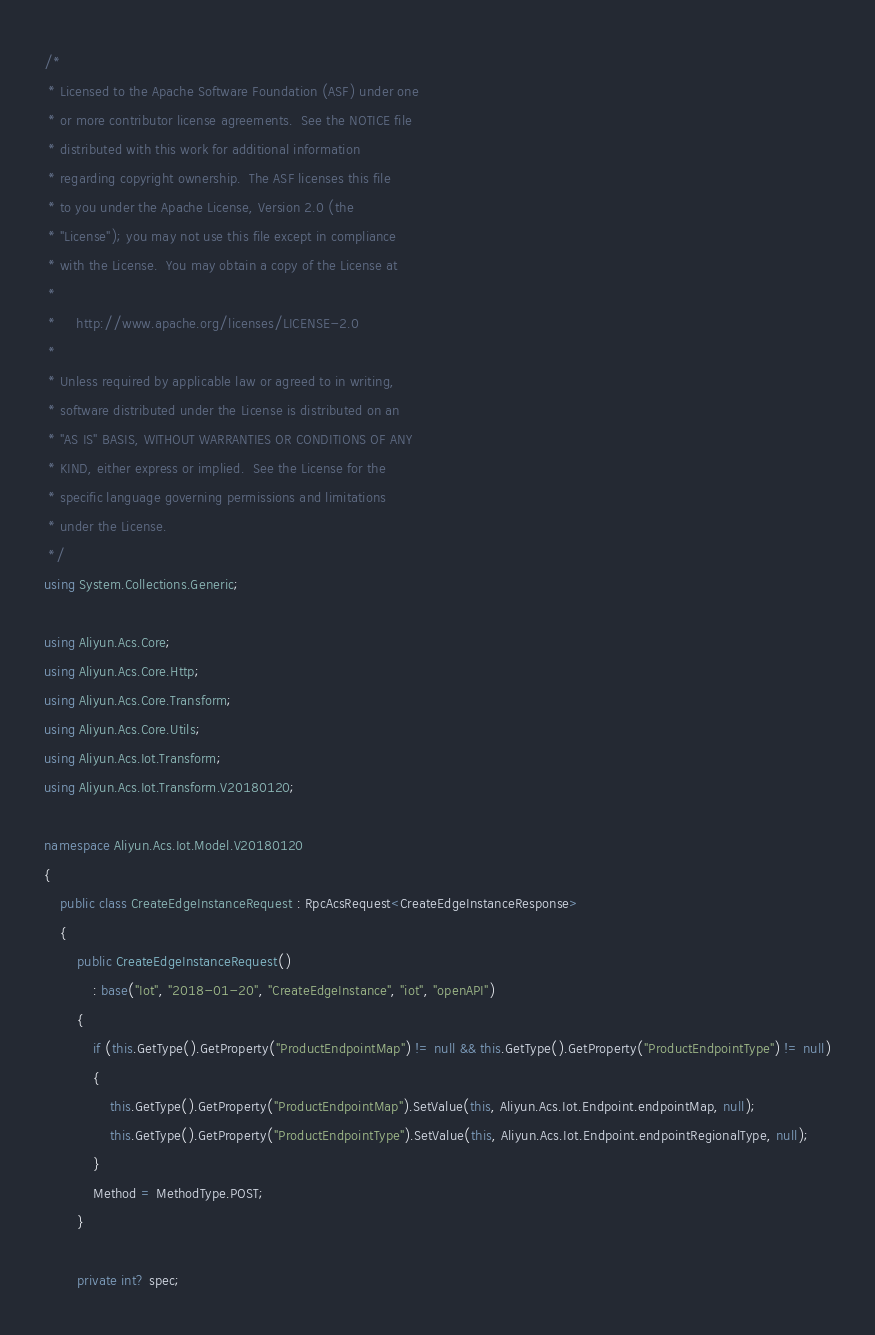Convert code to text. <code><loc_0><loc_0><loc_500><loc_500><_C#_>/*
 * Licensed to the Apache Software Foundation (ASF) under one
 * or more contributor license agreements.  See the NOTICE file
 * distributed with this work for additional information
 * regarding copyright ownership.  The ASF licenses this file
 * to you under the Apache License, Version 2.0 (the
 * "License"); you may not use this file except in compliance
 * with the License.  You may obtain a copy of the License at
 *
 *     http://www.apache.org/licenses/LICENSE-2.0
 *
 * Unless required by applicable law or agreed to in writing,
 * software distributed under the License is distributed on an
 * "AS IS" BASIS, WITHOUT WARRANTIES OR CONDITIONS OF ANY
 * KIND, either express or implied.  See the License for the
 * specific language governing permissions and limitations
 * under the License.
 */
using System.Collections.Generic;

using Aliyun.Acs.Core;
using Aliyun.Acs.Core.Http;
using Aliyun.Acs.Core.Transform;
using Aliyun.Acs.Core.Utils;
using Aliyun.Acs.Iot.Transform;
using Aliyun.Acs.Iot.Transform.V20180120;

namespace Aliyun.Acs.Iot.Model.V20180120
{
    public class CreateEdgeInstanceRequest : RpcAcsRequest<CreateEdgeInstanceResponse>
    {
        public CreateEdgeInstanceRequest()
            : base("Iot", "2018-01-20", "CreateEdgeInstance", "iot", "openAPI")
        {
            if (this.GetType().GetProperty("ProductEndpointMap") != null && this.GetType().GetProperty("ProductEndpointType") != null)
            {
                this.GetType().GetProperty("ProductEndpointMap").SetValue(this, Aliyun.Acs.Iot.Endpoint.endpointMap, null);
                this.GetType().GetProperty("ProductEndpointType").SetValue(this, Aliyun.Acs.Iot.Endpoint.endpointRegionalType, null);
            }
			Method = MethodType.POST;
        }

		private int? spec;
</code> 